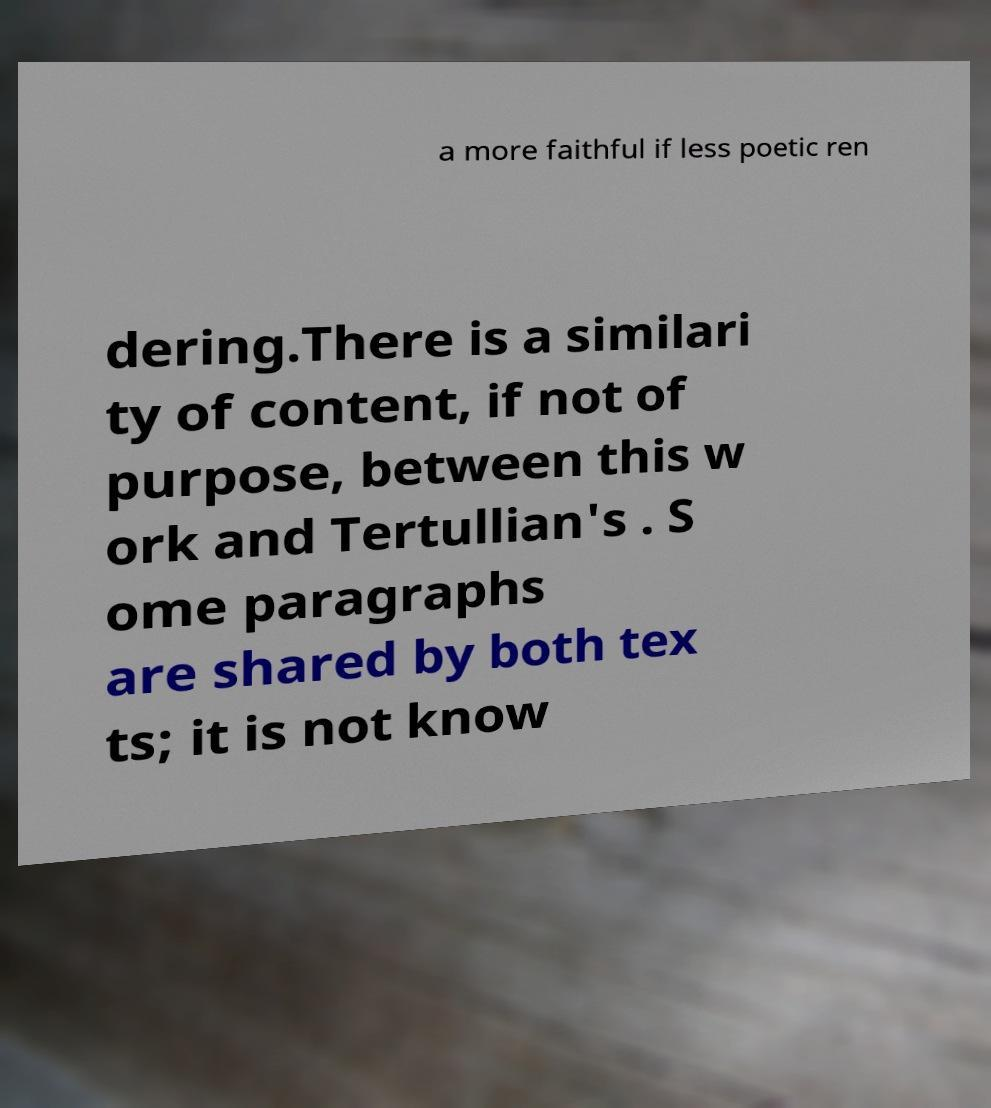Please read and relay the text visible in this image. What does it say? a more faithful if less poetic ren dering.There is a similari ty of content, if not of purpose, between this w ork and Tertullian's . S ome paragraphs are shared by both tex ts; it is not know 